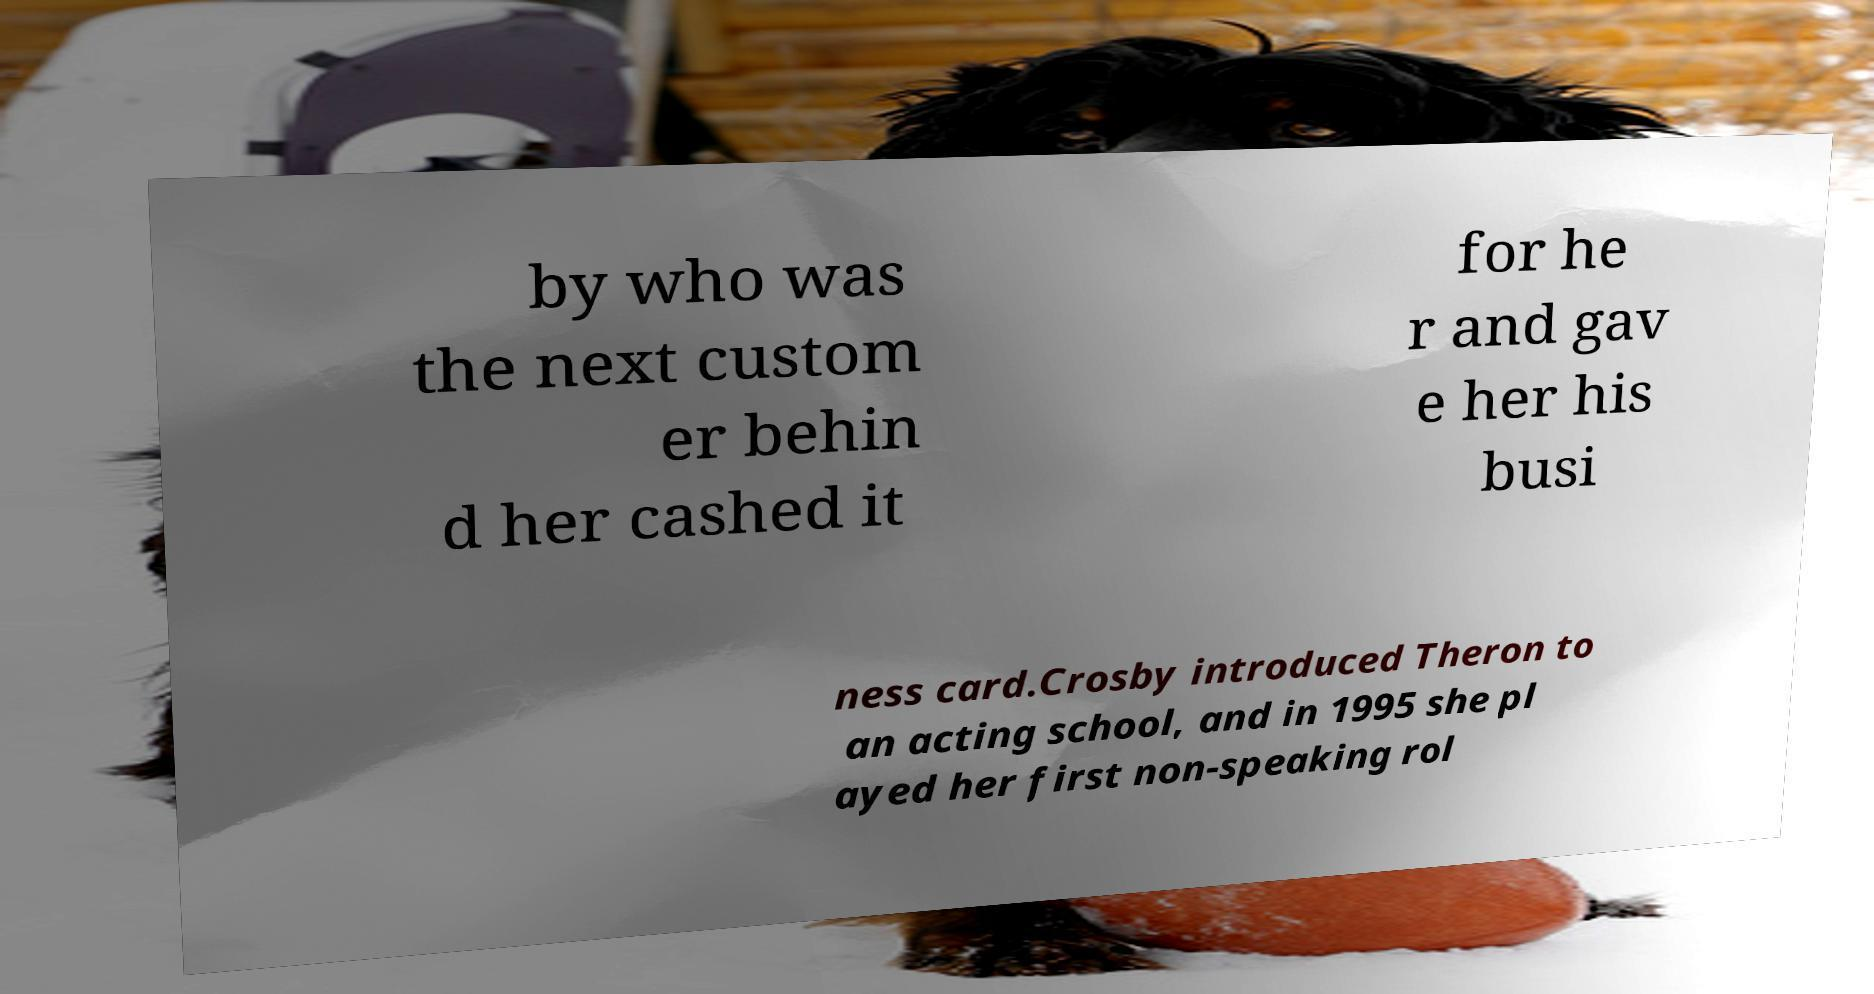I need the written content from this picture converted into text. Can you do that? by who was the next custom er behin d her cashed it for he r and gav e her his busi ness card.Crosby introduced Theron to an acting school, and in 1995 she pl ayed her first non-speaking rol 